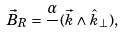Convert formula to latex. <formula><loc_0><loc_0><loc_500><loc_500>\vec { B } _ { R } = \frac { \alpha } { } ( \vec { k } \wedge \hat { k } _ { \perp } ) ,</formula> 